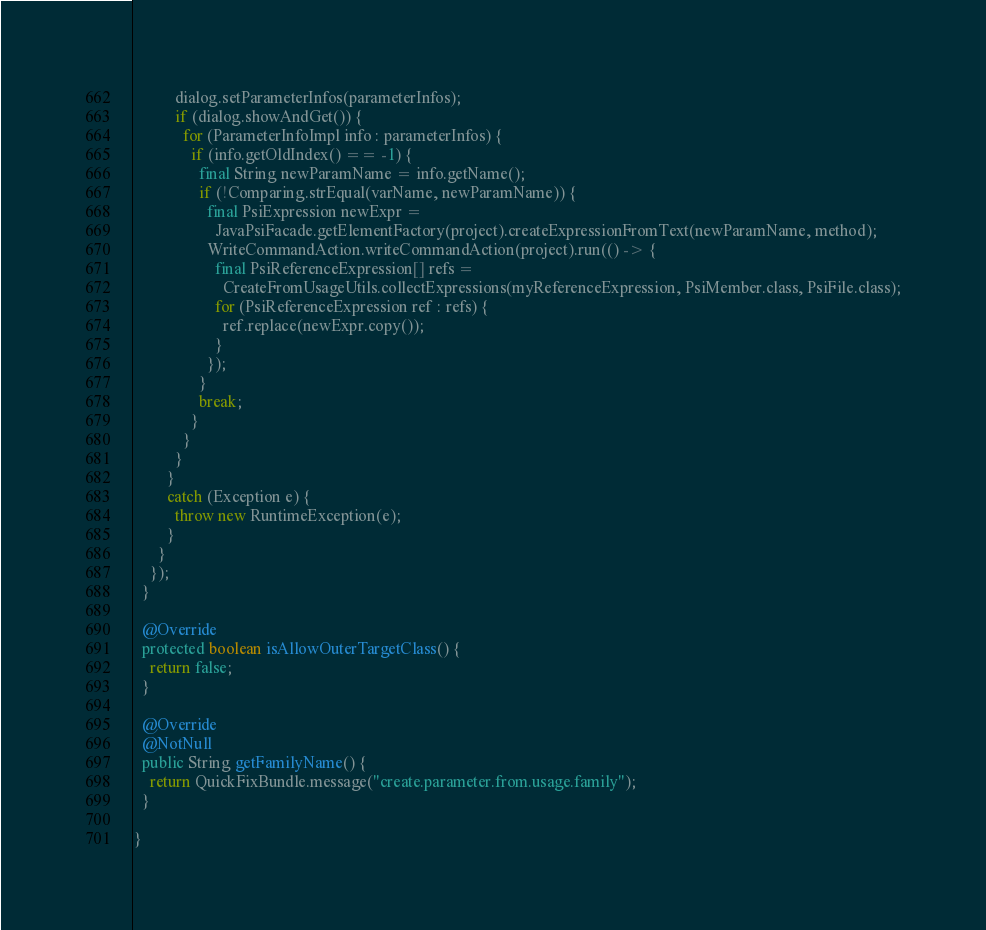Convert code to text. <code><loc_0><loc_0><loc_500><loc_500><_Java_>          dialog.setParameterInfos(parameterInfos);
          if (dialog.showAndGet()) {
            for (ParameterInfoImpl info : parameterInfos) {
              if (info.getOldIndex() == -1) {
                final String newParamName = info.getName();
                if (!Comparing.strEqual(varName, newParamName)) {
                  final PsiExpression newExpr =
                    JavaPsiFacade.getElementFactory(project).createExpressionFromText(newParamName, method);
                  WriteCommandAction.writeCommandAction(project).run(() -> {
                    final PsiReferenceExpression[] refs =
                      CreateFromUsageUtils.collectExpressions(myReferenceExpression, PsiMember.class, PsiFile.class);
                    for (PsiReferenceExpression ref : refs) {
                      ref.replace(newExpr.copy());
                    }
                  });
                }
                break;
              }
            }
          }
        }
        catch (Exception e) {
          throw new RuntimeException(e);
        }
      }
    });
  }

  @Override
  protected boolean isAllowOuterTargetClass() {
    return false;
  }

  @Override
  @NotNull
  public String getFamilyName() {
    return QuickFixBundle.message("create.parameter.from.usage.family");
  }

}
</code> 